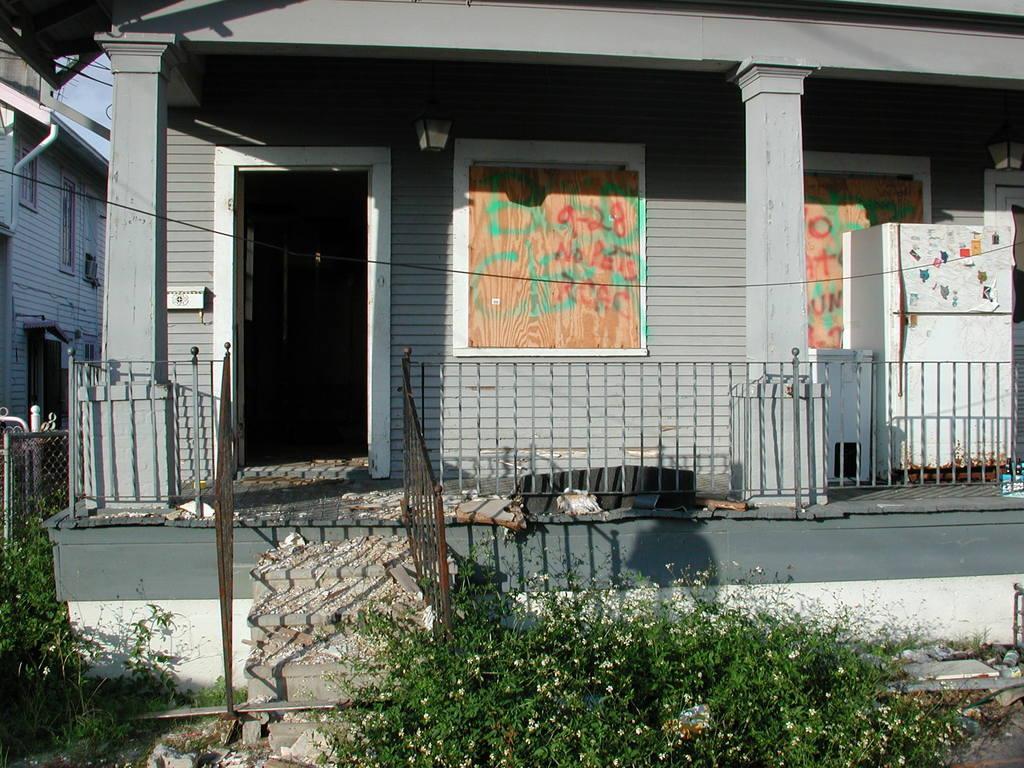How would you summarize this image in a sentence or two? In this image, there are a few houses. We can see some stairs and the railing. We can see the fence. We can see a refrigerator and some objects. We can see some posters on the wall. We can see some plants with flowers. We can see the ground with some objects. We can see some wires and the sky 